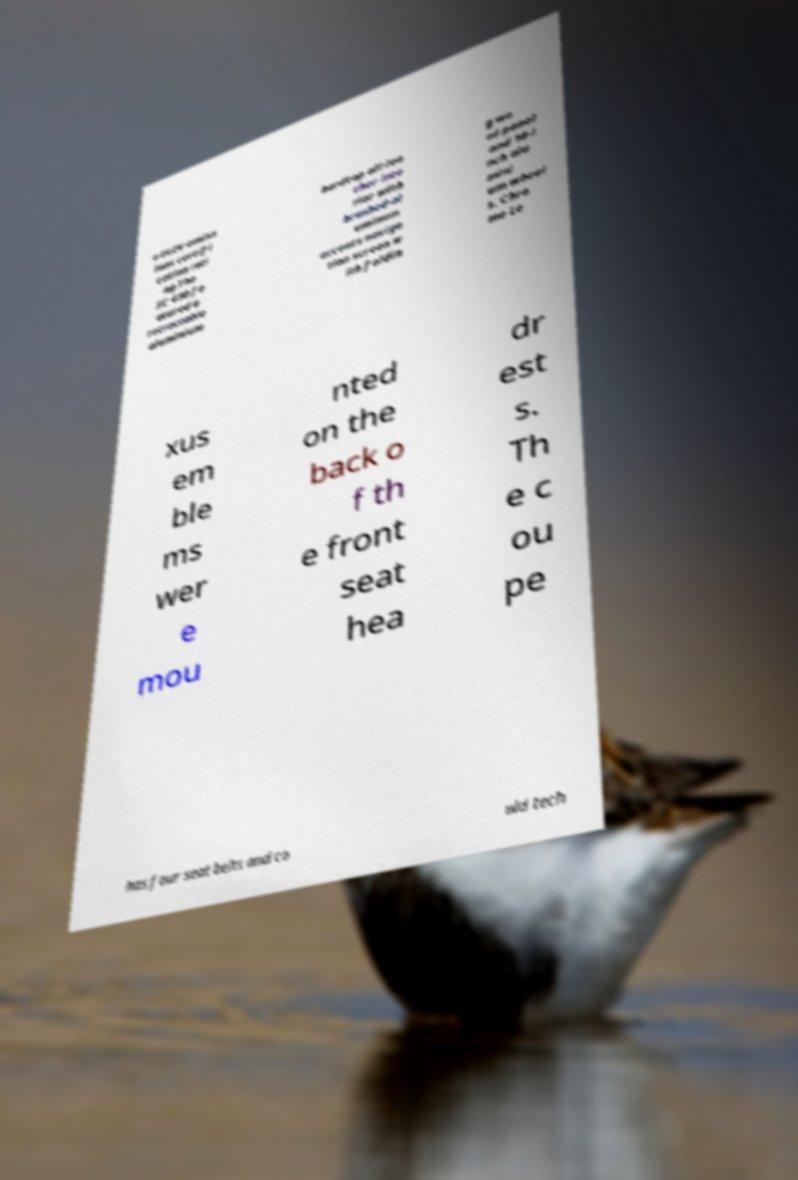I need the written content from this picture converted into text. Can you do that? a ULEV emiss ions certifi cation rati ng.The SC 430 fe atured a retractable aluminium hardtop all-lea ther inte rior with brushed-al uminum accents naviga tion screen w ith foldin g wo od panel and 18-i nch alu mini um wheel s. Chro me Le xus em ble ms wer e mou nted on the back o f th e front seat hea dr est s. Th e c ou pe has four seat belts and co uld tech 